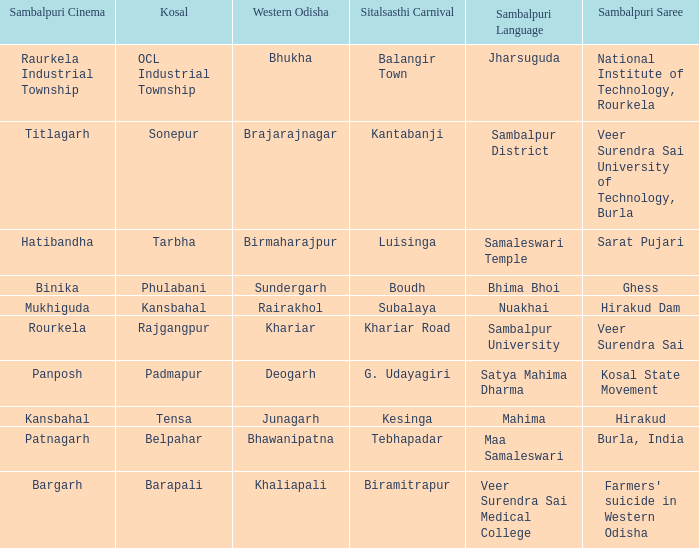Parse the table in full. {'header': ['Sambalpuri Cinema', 'Kosal', 'Western Odisha', 'Sitalsasthi Carnival', 'Sambalpuri Language', 'Sambalpuri Saree'], 'rows': [['Raurkela Industrial Township', 'OCL Industrial Township', 'Bhukha', 'Balangir Town', 'Jharsuguda', 'National Institute of Technology, Rourkela'], ['Titlagarh', 'Sonepur', 'Brajarajnagar', 'Kantabanji', 'Sambalpur District', 'Veer Surendra Sai University of Technology, Burla'], ['Hatibandha', 'Tarbha', 'Birmaharajpur', 'Luisinga', 'Samaleswari Temple', 'Sarat Pujari'], ['Binika', 'Phulabani', 'Sundergarh', 'Boudh', 'Bhima Bhoi', 'Ghess'], ['Mukhiguda', 'Kansbahal', 'Rairakhol', 'Subalaya', 'Nuakhai', 'Hirakud Dam'], ['Rourkela', 'Rajgangpur', 'Khariar', 'Khariar Road', 'Sambalpur University', 'Veer Surendra Sai'], ['Panposh', 'Padmapur', 'Deogarh', 'G. Udayagiri', 'Satya Mahima Dharma', 'Kosal State Movement'], ['Kansbahal', 'Tensa', 'Junagarh', 'Kesinga', 'Mahima', 'Hirakud'], ['Patnagarh', 'Belpahar', 'Bhawanipatna', 'Tebhapadar', 'Maa Samaleswari', 'Burla, India'], ['Bargarh', 'Barapali', 'Khaliapali', 'Biramitrapur', 'Veer Surendra Sai Medical College', "Farmers' suicide in Western Odisha"]]} What is the sitalsasthi carnival with sonepur as kosal? Kantabanji. 